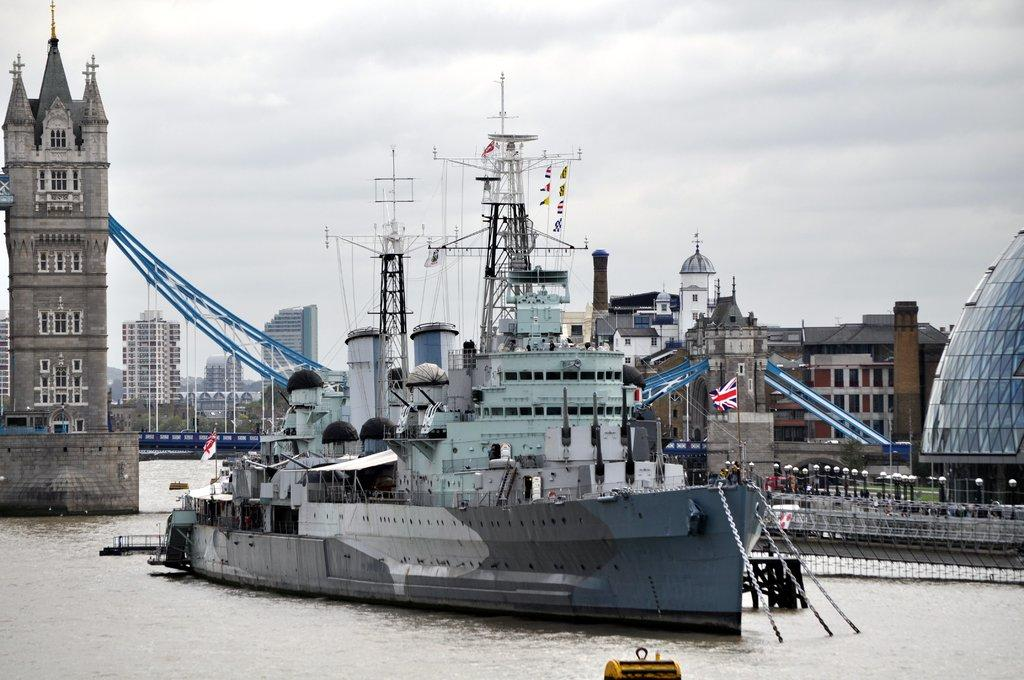What is the main subject in the image? There is a ship in the river in the image. What is located on the left side of the image? There is a tower bridge on the left side of the image. What can be seen on the right side of the image? There are flags, lamp posts, and buildings on the right side of the image. Where is the crowd gathered in the image? There is no crowd present in the image. Can you tell me what type of animals are in the zoo in the image? There is no zoo present in the image. 